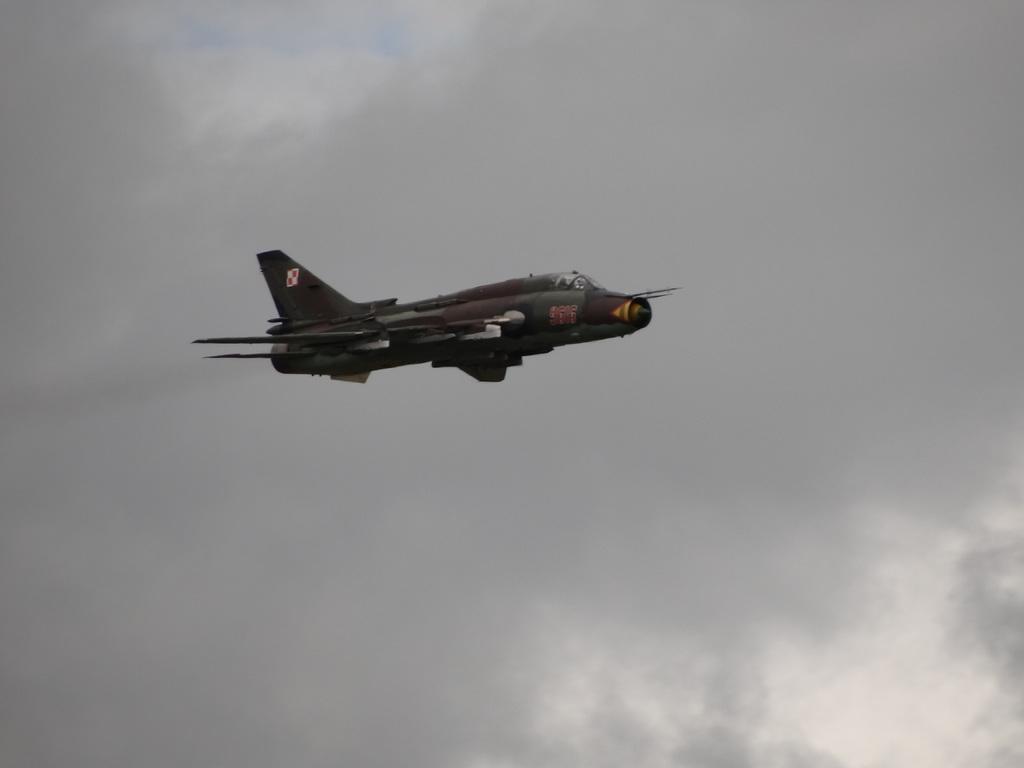Can you describe this image briefly? In this image there is an aircraft flying in the air. In the background there is the sky. 